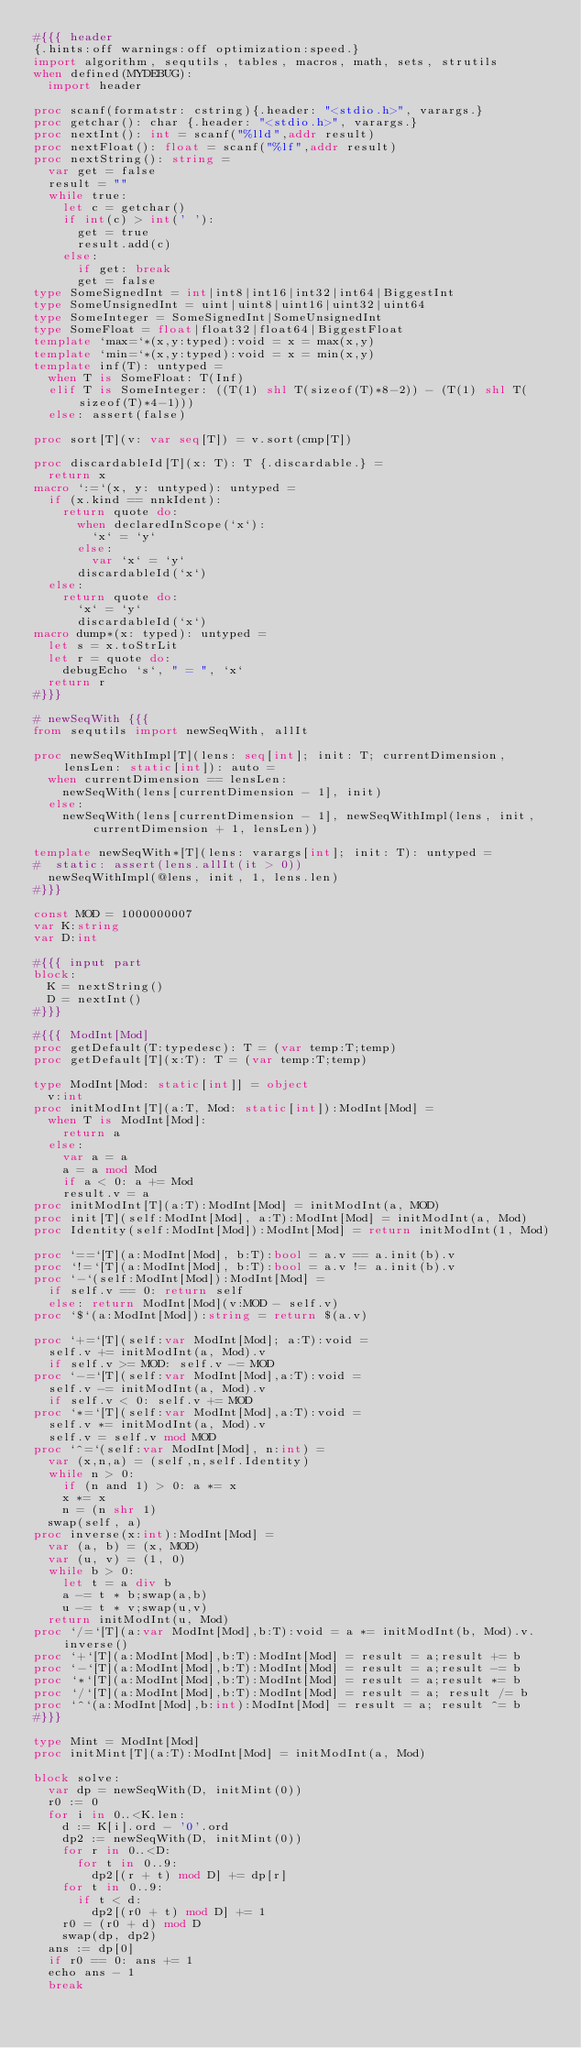Convert code to text. <code><loc_0><loc_0><loc_500><loc_500><_Nim_>#{{{ header
{.hints:off warnings:off optimization:speed.}
import algorithm, sequtils, tables, macros, math, sets, strutils
when defined(MYDEBUG):
  import header

proc scanf(formatstr: cstring){.header: "<stdio.h>", varargs.}
proc getchar(): char {.header: "<stdio.h>", varargs.}
proc nextInt(): int = scanf("%lld",addr result)
proc nextFloat(): float = scanf("%lf",addr result)
proc nextString(): string =
  var get = false
  result = ""
  while true:
    let c = getchar()
    if int(c) > int(' '):
      get = true
      result.add(c)
    else:
      if get: break
      get = false
type SomeSignedInt = int|int8|int16|int32|int64|BiggestInt
type SomeUnsignedInt = uint|uint8|uint16|uint32|uint64
type SomeInteger = SomeSignedInt|SomeUnsignedInt
type SomeFloat = float|float32|float64|BiggestFloat
template `max=`*(x,y:typed):void = x = max(x,y)
template `min=`*(x,y:typed):void = x = min(x,y)
template inf(T): untyped = 
  when T is SomeFloat: T(Inf)
  elif T is SomeInteger: ((T(1) shl T(sizeof(T)*8-2)) - (T(1) shl T(sizeof(T)*4-1)))
  else: assert(false)

proc sort[T](v: var seq[T]) = v.sort(cmp[T])

proc discardableId[T](x: T): T {.discardable.} =
  return x
macro `:=`(x, y: untyped): untyped =
  if (x.kind == nnkIdent):
    return quote do:
      when declaredInScope(`x`):
        `x` = `y`
      else:
        var `x` = `y`
      discardableId(`x`)
  else:
    return quote do:
      `x` = `y`
      discardableId(`x`)
macro dump*(x: typed): untyped =
  let s = x.toStrLit
  let r = quote do:
    debugEcho `s`, " = ", `x`
  return r
#}}}

# newSeqWith {{{
from sequtils import newSeqWith, allIt

proc newSeqWithImpl[T](lens: seq[int]; init: T; currentDimension, lensLen: static[int]): auto =
  when currentDimension == lensLen:
    newSeqWith(lens[currentDimension - 1], init)
  else:
    newSeqWith(lens[currentDimension - 1], newSeqWithImpl(lens, init, currentDimension + 1, lensLen))

template newSeqWith*[T](lens: varargs[int]; init: T): untyped =
#  static: assert(lens.allIt(it > 0))
  newSeqWithImpl(@lens, init, 1, lens.len)
#}}}

const MOD = 1000000007
var K:string
var D:int

#{{{ input part
block:
  K = nextString()
  D = nextInt()
#}}}

#{{{ ModInt[Mod]
proc getDefault(T:typedesc): T = (var temp:T;temp)
proc getDefault[T](x:T): T = (var temp:T;temp)

type ModInt[Mod: static[int]] = object
  v:int
proc initModInt[T](a:T, Mod: static[int]):ModInt[Mod] =
  when T is ModInt[Mod]:
    return a
  else:
    var a = a
    a = a mod Mod
    if a < 0: a += Mod
    result.v = a
proc initModInt[T](a:T):ModInt[Mod] = initModInt(a, MOD)
proc init[T](self:ModInt[Mod], a:T):ModInt[Mod] = initModInt(a, Mod)
proc Identity(self:ModInt[Mod]):ModInt[Mod] = return initModInt(1, Mod)

proc `==`[T](a:ModInt[Mod], b:T):bool = a.v == a.init(b).v
proc `!=`[T](a:ModInt[Mod], b:T):bool = a.v != a.init(b).v
proc `-`(self:ModInt[Mod]):ModInt[Mod] =
  if self.v == 0: return self
  else: return ModInt[Mod](v:MOD - self.v)
proc `$`(a:ModInt[Mod]):string = return $(a.v)

proc `+=`[T](self:var ModInt[Mod]; a:T):void =
  self.v += initModInt(a, Mod).v
  if self.v >= MOD: self.v -= MOD
proc `-=`[T](self:var ModInt[Mod],a:T):void =
  self.v -= initModInt(a, Mod).v
  if self.v < 0: self.v += MOD
proc `*=`[T](self:var ModInt[Mod],a:T):void =
  self.v *= initModInt(a, Mod).v
  self.v = self.v mod MOD
proc `^=`(self:var ModInt[Mod], n:int) =
  var (x,n,a) = (self,n,self.Identity)
  while n > 0:
    if (n and 1) > 0: a *= x
    x *= x
    n = (n shr 1)
  swap(self, a)
proc inverse(x:int):ModInt[Mod] =
  var (a, b) = (x, MOD)
  var (u, v) = (1, 0)
  while b > 0:
    let t = a div b
    a -= t * b;swap(a,b)
    u -= t * v;swap(u,v)
  return initModInt(u, Mod)
proc `/=`[T](a:var ModInt[Mod],b:T):void = a *= initModInt(b, Mod).v.inverse()
proc `+`[T](a:ModInt[Mod],b:T):ModInt[Mod] = result = a;result += b
proc `-`[T](a:ModInt[Mod],b:T):ModInt[Mod] = result = a;result -= b
proc `*`[T](a:ModInt[Mod],b:T):ModInt[Mod] = result = a;result *= b
proc `/`[T](a:ModInt[Mod],b:T):ModInt[Mod] = result = a; result /= b
proc `^`(a:ModInt[Mod],b:int):ModInt[Mod] = result = a; result ^= b
#}}}

type Mint = ModInt[Mod]
proc initMint[T](a:T):ModInt[Mod] = initModInt(a, Mod)

block solve:
  var dp = newSeqWith(D, initMint(0))
  r0 := 0
  for i in 0..<K.len:
    d := K[i].ord - '0'.ord
    dp2 := newSeqWith(D, initMint(0))
    for r in 0..<D:
      for t in 0..9:
        dp2[(r + t) mod D] += dp[r]
    for t in 0..9:
      if t < d:
        dp2[(r0 + t) mod D] += 1
    r0 = (r0 + d) mod D
    swap(dp, dp2)
  ans := dp[0]
  if r0 == 0: ans += 1
  echo ans - 1
  break

</code> 